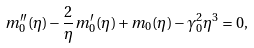<formula> <loc_0><loc_0><loc_500><loc_500>m _ { 0 } ^ { \prime \prime } ( \eta ) - \frac { 2 } { \eta } m _ { 0 } ^ { \prime } ( \eta ) + m _ { 0 } ( \eta ) - \gamma _ { 0 } ^ { 2 } \eta ^ { 3 } = 0 ,</formula> 